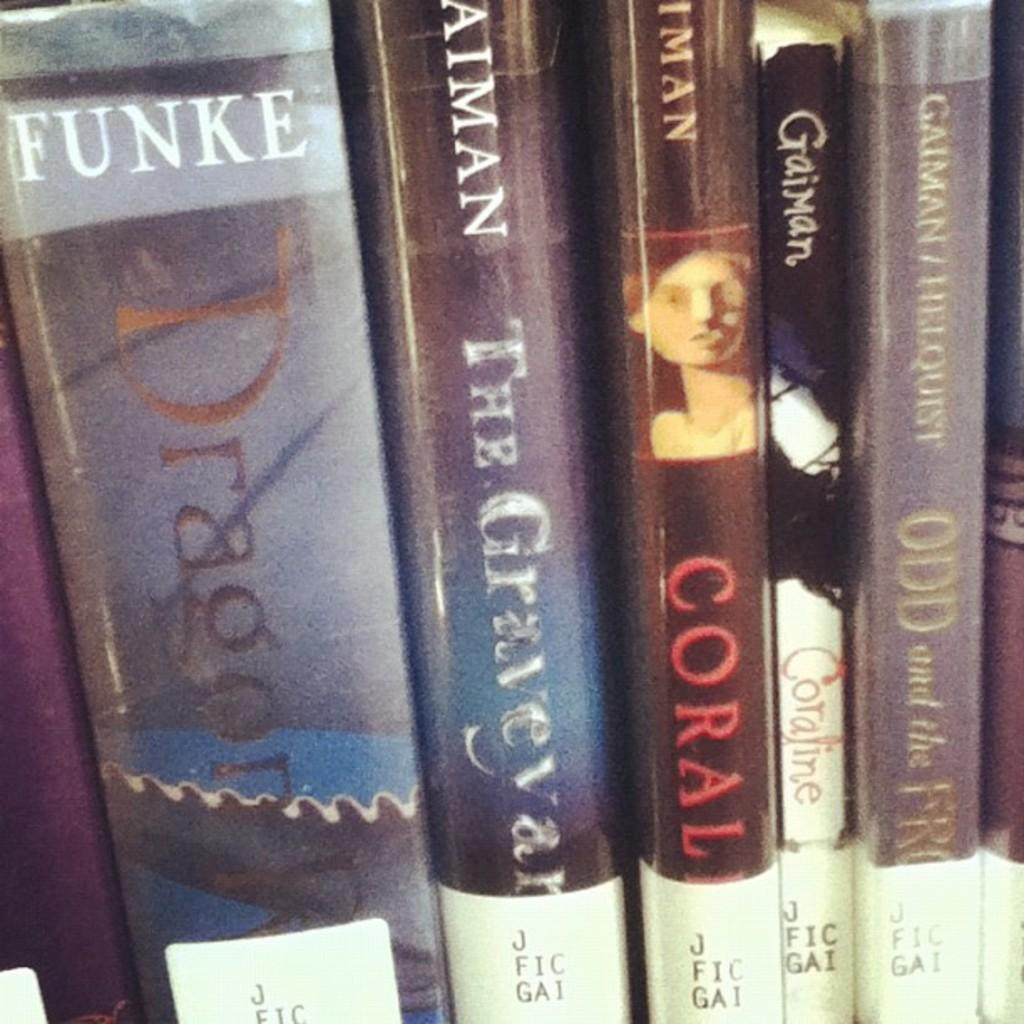<image>
Provide a brief description of the given image. Several books are lined up next to each other, including one by Funke. 